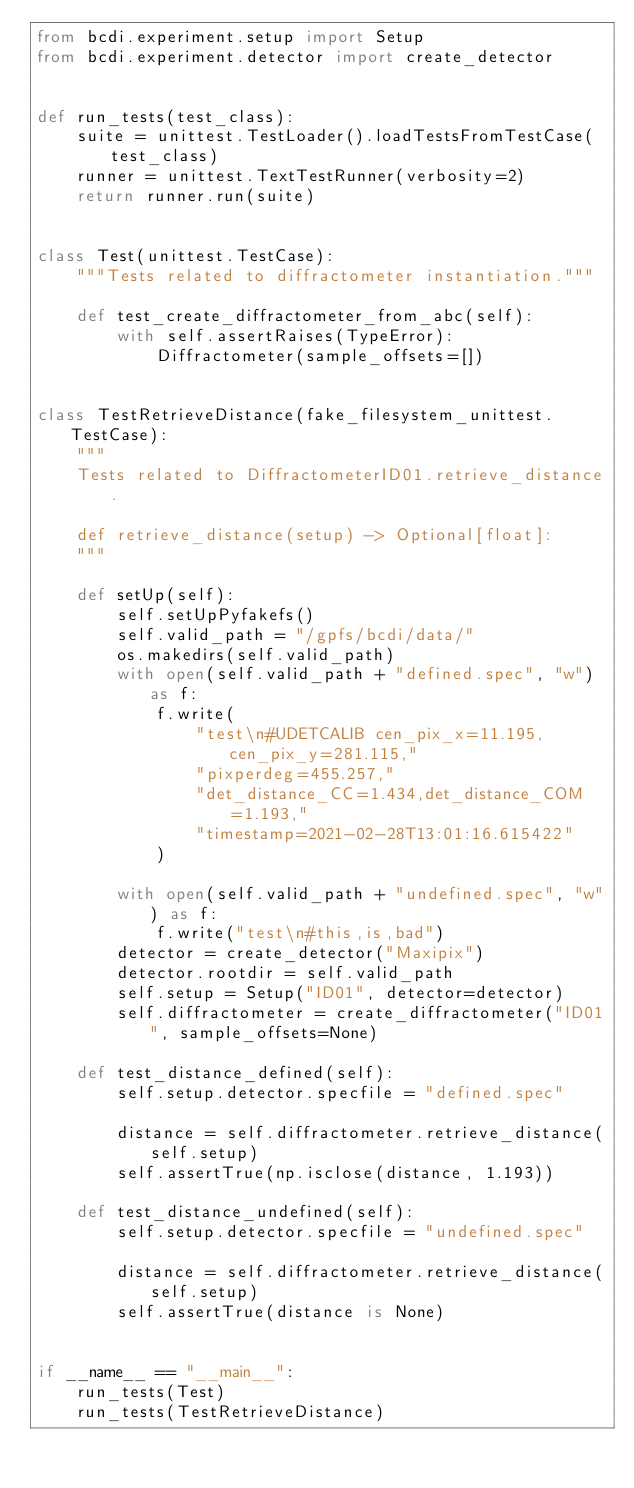<code> <loc_0><loc_0><loc_500><loc_500><_Python_>from bcdi.experiment.setup import Setup
from bcdi.experiment.detector import create_detector


def run_tests(test_class):
    suite = unittest.TestLoader().loadTestsFromTestCase(test_class)
    runner = unittest.TextTestRunner(verbosity=2)
    return runner.run(suite)


class Test(unittest.TestCase):
    """Tests related to diffractometer instantiation."""

    def test_create_diffractometer_from_abc(self):
        with self.assertRaises(TypeError):
            Diffractometer(sample_offsets=[])


class TestRetrieveDistance(fake_filesystem_unittest.TestCase):
    """
    Tests related to DiffractometerID01.retrieve_distance.

    def retrieve_distance(setup) -> Optional[float]:
    """

    def setUp(self):
        self.setUpPyfakefs()
        self.valid_path = "/gpfs/bcdi/data/"
        os.makedirs(self.valid_path)
        with open(self.valid_path + "defined.spec", "w") as f:
            f.write(
                "test\n#UDETCALIB cen_pix_x=11.195,cen_pix_y=281.115,"
                "pixperdeg=455.257,"
                "det_distance_CC=1.434,det_distance_COM=1.193,"
                "timestamp=2021-02-28T13:01:16.615422"
            )

        with open(self.valid_path + "undefined.spec", "w") as f:
            f.write("test\n#this,is,bad")
        detector = create_detector("Maxipix")
        detector.rootdir = self.valid_path
        self.setup = Setup("ID01", detector=detector)
        self.diffractometer = create_diffractometer("ID01", sample_offsets=None)

    def test_distance_defined(self):
        self.setup.detector.specfile = "defined.spec"

        distance = self.diffractometer.retrieve_distance(self.setup)
        self.assertTrue(np.isclose(distance, 1.193))

    def test_distance_undefined(self):
        self.setup.detector.specfile = "undefined.spec"

        distance = self.diffractometer.retrieve_distance(self.setup)
        self.assertTrue(distance is None)


if __name__ == "__main__":
    run_tests(Test)
    run_tests(TestRetrieveDistance)
</code> 